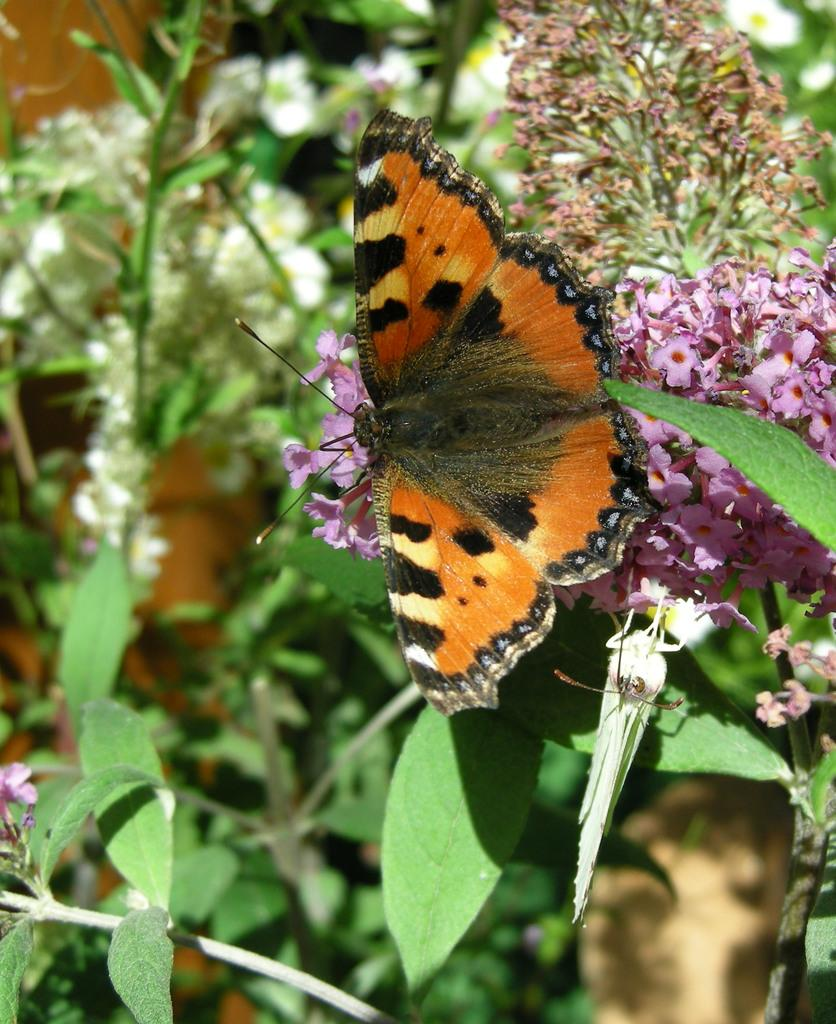What is the main subject of the picture? The main subject of the picture is a butterfly. Where is the butterfly located in the picture? The butterfly is sitting on flowers in the picture. What else can be seen in the picture besides the butterfly? There are different plants in the picture. What are the plants in the picture characterized by? The plants in the picture have leaves. What type of carpenter is working on the tomatoes in the picture? There is no carpenter or tomatoes present in the picture; it features a butterfly sitting on flowers. How many spots can be seen on the butterfly in the picture? The butterfly in the picture does not have any visible spots. 